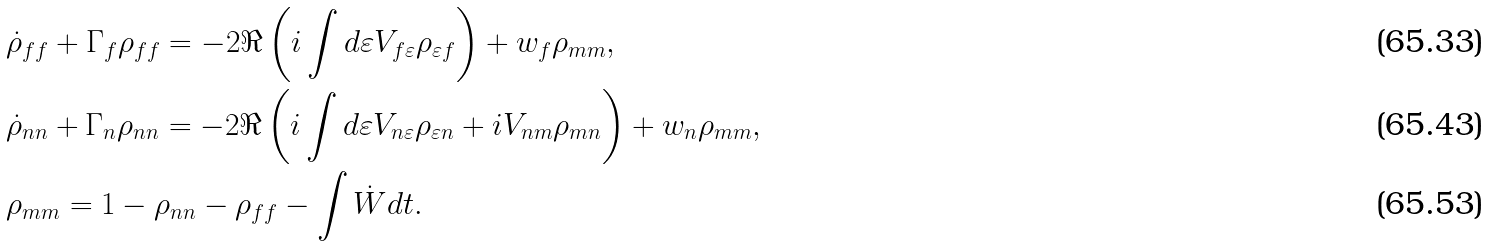Convert formula to latex. <formula><loc_0><loc_0><loc_500><loc_500>& \dot { \rho } _ { f f } + \Gamma _ { f } \rho _ { f f } = - 2 \Re \left ( i \int d \varepsilon V _ { f \varepsilon } \rho _ { \varepsilon f } \right ) + w _ { f } \rho _ { m m } , \\ & \dot { \rho } _ { n n } + \Gamma _ { n } \rho _ { n n } = - 2 \Re \left ( i \int d \varepsilon V _ { n \varepsilon } \rho _ { \varepsilon n } + i V _ { n m } \rho _ { m n } \right ) + w _ { n } \rho _ { m m } , \\ & \rho _ { m m } = 1 - \rho _ { n n } - \rho _ { f f } - \int \dot { W } d t .</formula> 